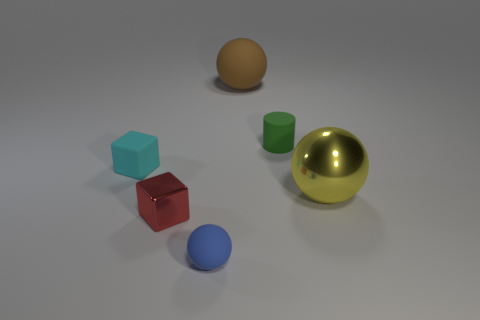What color is the ball behind the thing right of the green rubber cylinder?
Ensure brevity in your answer.  Brown. How many big brown balls are left of the green cylinder?
Offer a very short reply. 1. The tiny matte ball is what color?
Make the answer very short. Blue. How many small objects are matte cylinders or purple rubber things?
Your response must be concise. 1. How many other things are there of the same color as the tiny cylinder?
Offer a very short reply. 0. There is a object that is on the right side of the tiny rubber cylinder; what is its shape?
Offer a very short reply. Sphere. Is the number of small blue blocks less than the number of green cylinders?
Offer a terse response. Yes. Are the tiny thing right of the blue ball and the brown object made of the same material?
Provide a succinct answer. Yes. Are there any shiny things behind the cyan matte block?
Provide a short and direct response. No. What color is the thing behind the tiny thing that is right of the matte thing in front of the yellow sphere?
Your response must be concise. Brown. 